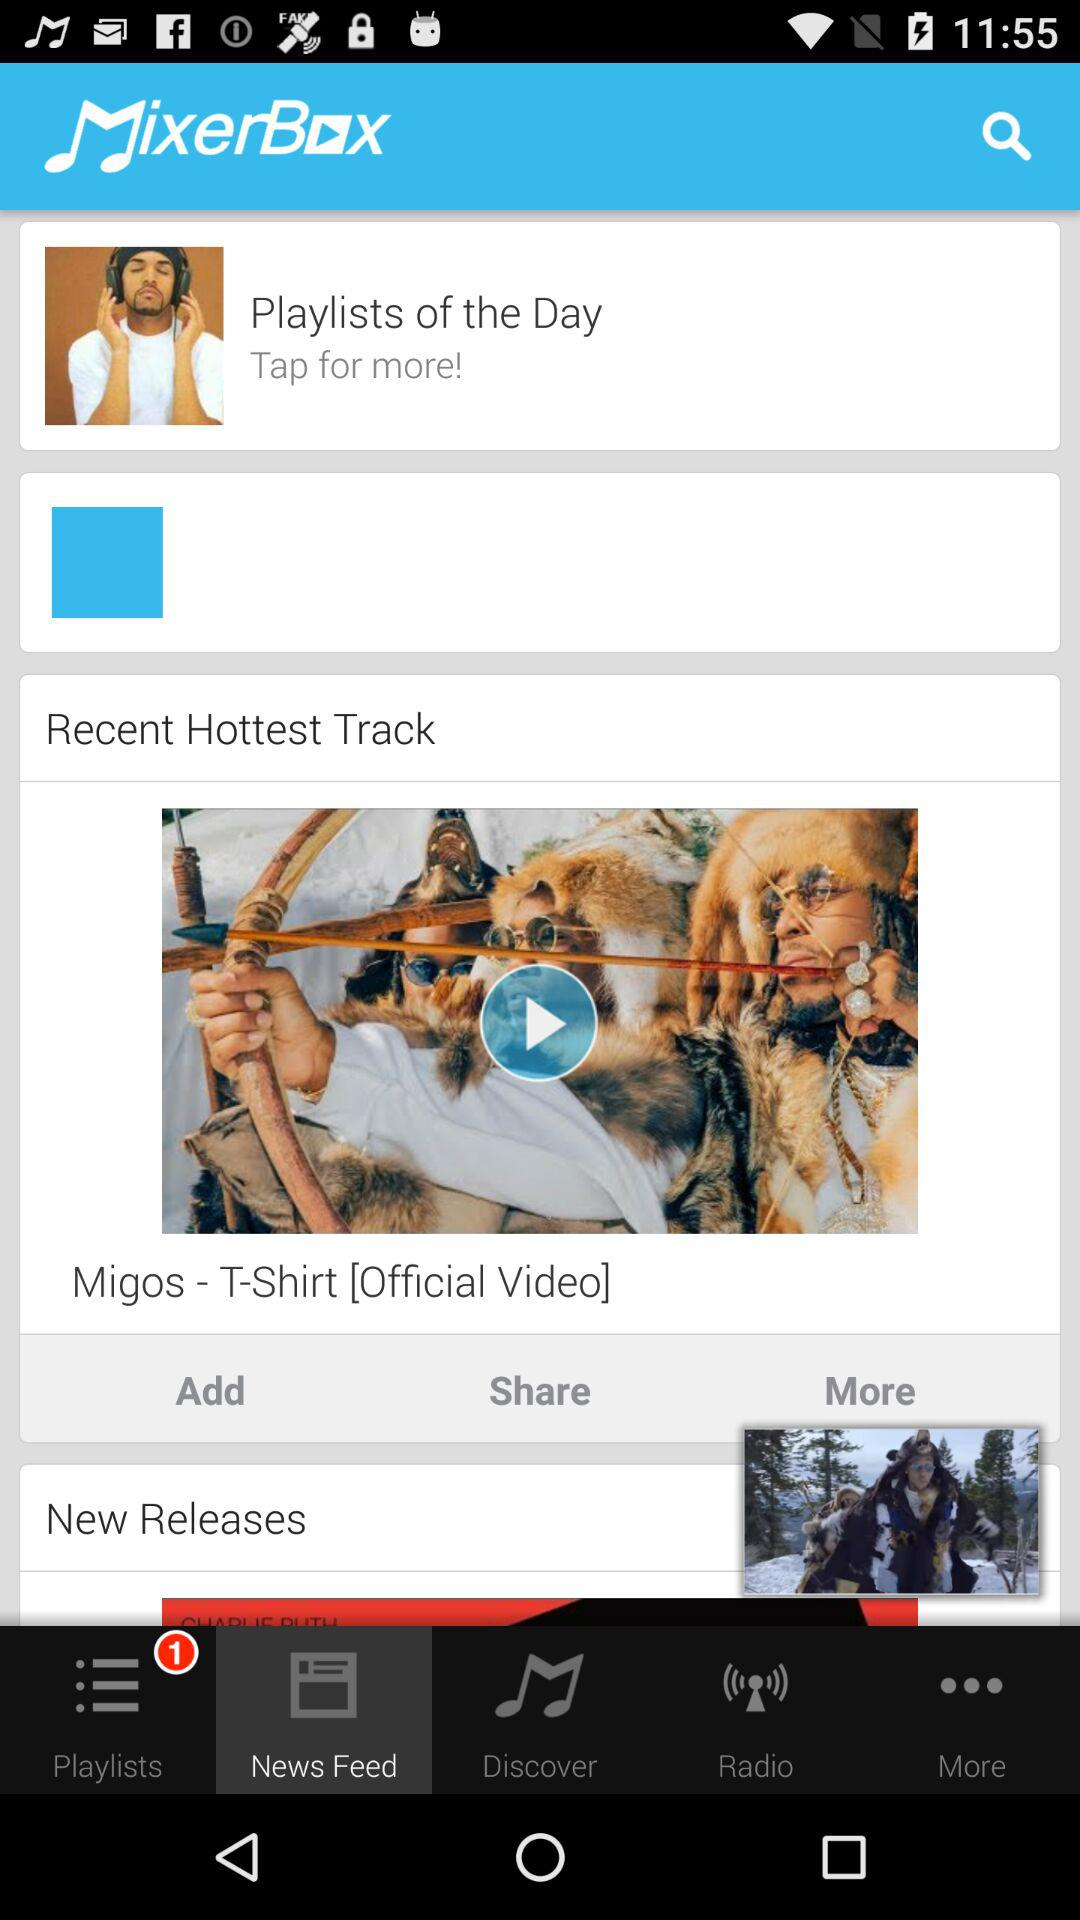How many notifications are there in "Discover"?
When the provided information is insufficient, respond with <no answer>. <no answer> 